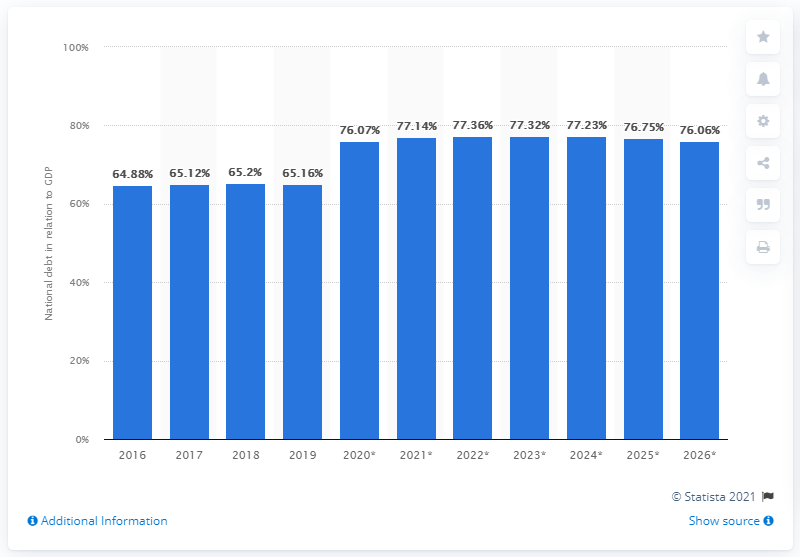Draw attention to some important aspects in this diagram. The national debt of Morocco in 2019 was 65.16. 